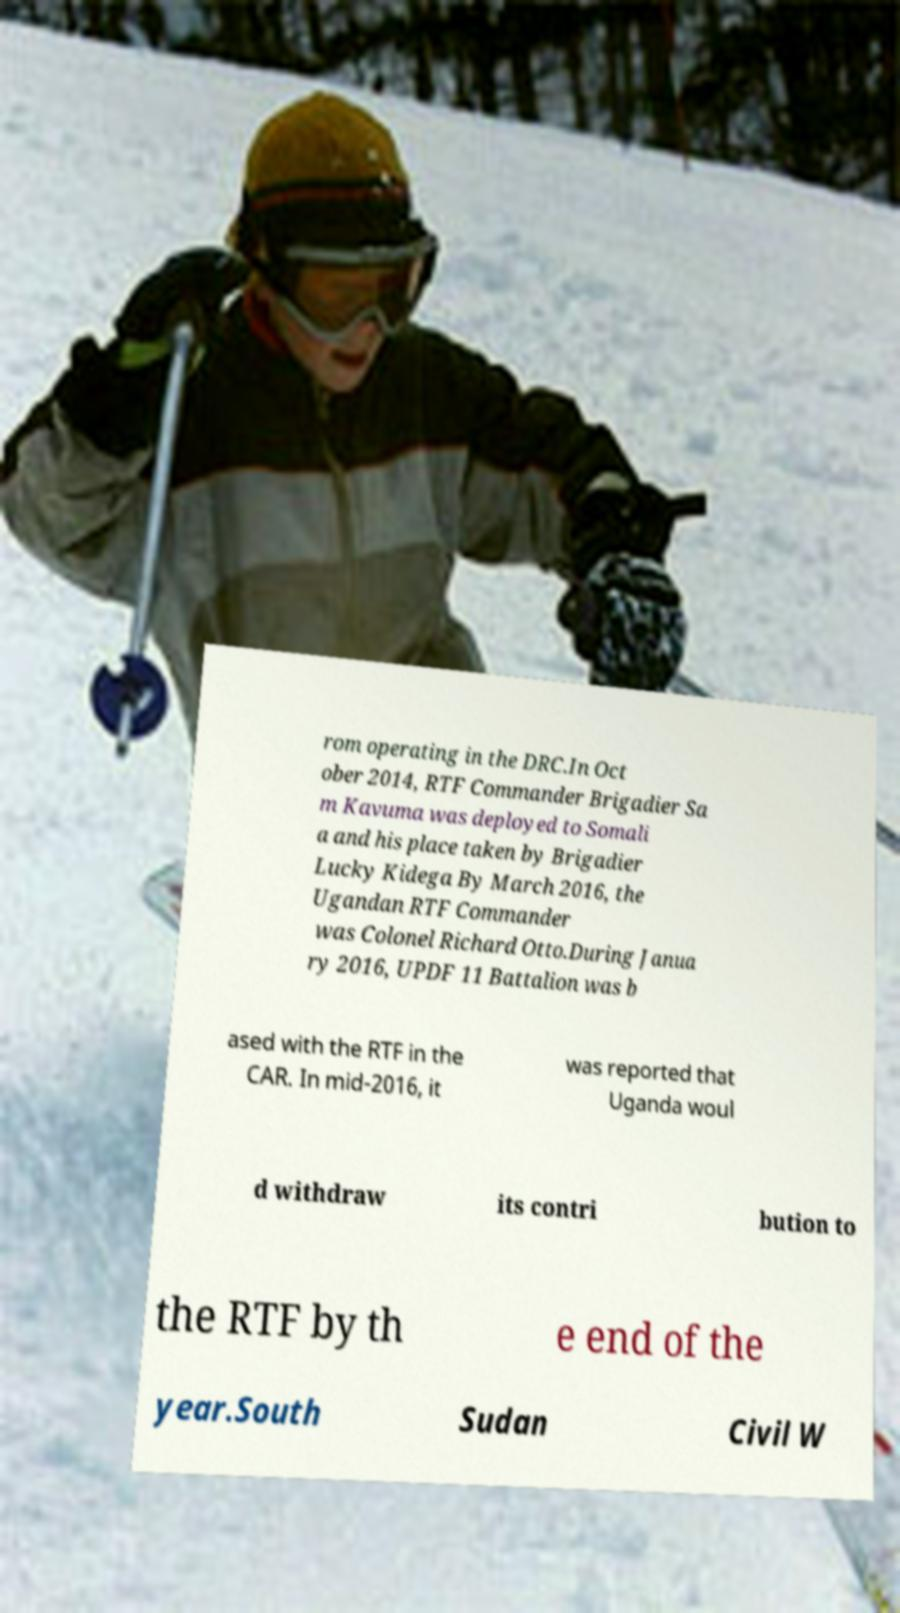Please read and relay the text visible in this image. What does it say? rom operating in the DRC.In Oct ober 2014, RTF Commander Brigadier Sa m Kavuma was deployed to Somali a and his place taken by Brigadier Lucky Kidega By March 2016, the Ugandan RTF Commander was Colonel Richard Otto.During Janua ry 2016, UPDF 11 Battalion was b ased with the RTF in the CAR. In mid-2016, it was reported that Uganda woul d withdraw its contri bution to the RTF by th e end of the year.South Sudan Civil W 